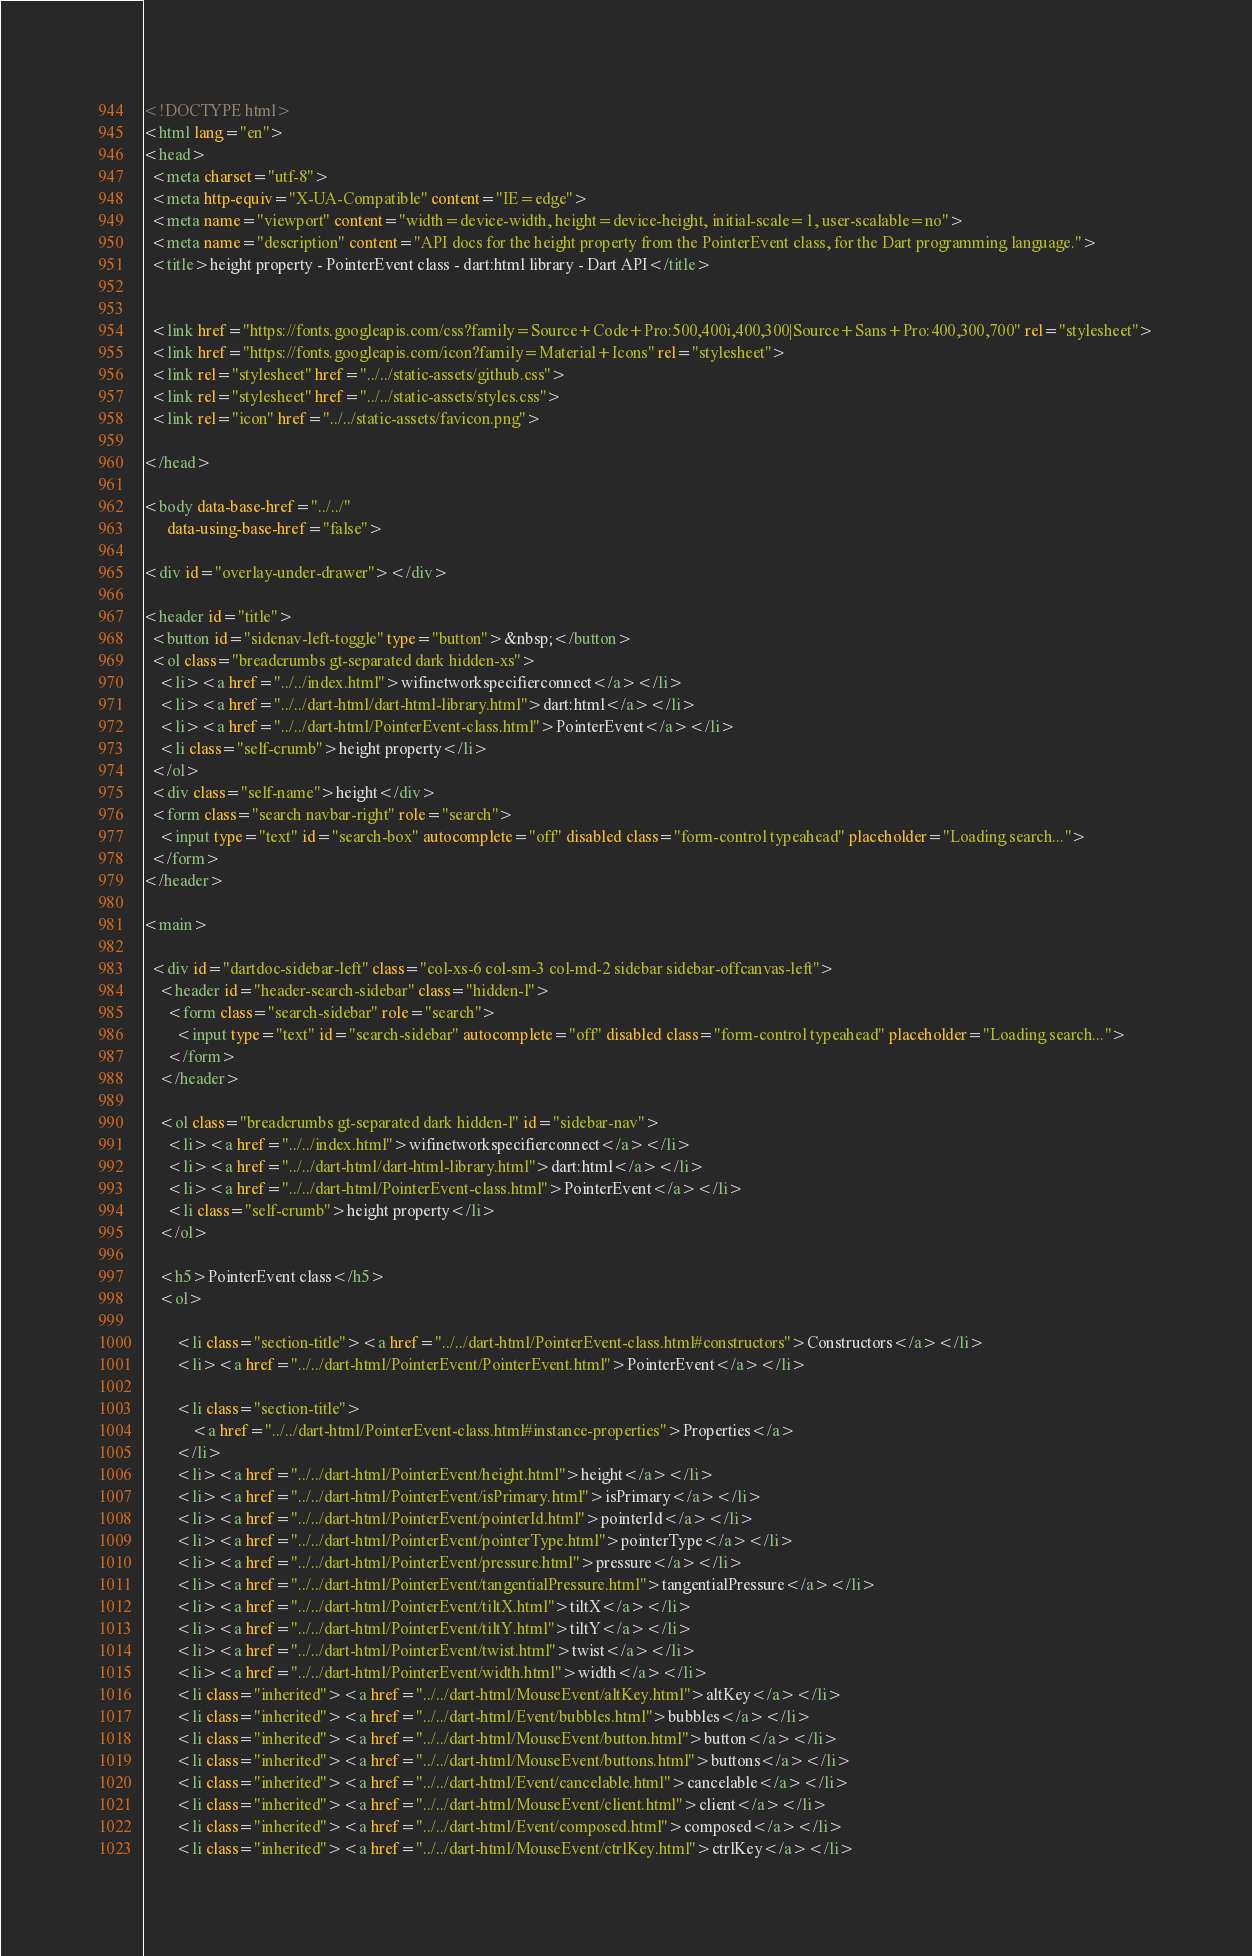Convert code to text. <code><loc_0><loc_0><loc_500><loc_500><_HTML_><!DOCTYPE html>
<html lang="en">
<head>
  <meta charset="utf-8">
  <meta http-equiv="X-UA-Compatible" content="IE=edge">
  <meta name="viewport" content="width=device-width, height=device-height, initial-scale=1, user-scalable=no">
  <meta name="description" content="API docs for the height property from the PointerEvent class, for the Dart programming language.">
  <title>height property - PointerEvent class - dart:html library - Dart API</title>

  
  <link href="https://fonts.googleapis.com/css?family=Source+Code+Pro:500,400i,400,300|Source+Sans+Pro:400,300,700" rel="stylesheet">
  <link href="https://fonts.googleapis.com/icon?family=Material+Icons" rel="stylesheet">
  <link rel="stylesheet" href="../../static-assets/github.css">
  <link rel="stylesheet" href="../../static-assets/styles.css">
  <link rel="icon" href="../../static-assets/favicon.png">

</head>

<body data-base-href="../../"
      data-using-base-href="false">

<div id="overlay-under-drawer"></div>

<header id="title">
  <button id="sidenav-left-toggle" type="button">&nbsp;</button>
  <ol class="breadcrumbs gt-separated dark hidden-xs">
    <li><a href="../../index.html">wifinetworkspecifierconnect</a></li>
    <li><a href="../../dart-html/dart-html-library.html">dart:html</a></li>
    <li><a href="../../dart-html/PointerEvent-class.html">PointerEvent</a></li>
    <li class="self-crumb">height property</li>
  </ol>
  <div class="self-name">height</div>
  <form class="search navbar-right" role="search">
    <input type="text" id="search-box" autocomplete="off" disabled class="form-control typeahead" placeholder="Loading search...">
  </form>
</header>

<main>

  <div id="dartdoc-sidebar-left" class="col-xs-6 col-sm-3 col-md-2 sidebar sidebar-offcanvas-left">
    <header id="header-search-sidebar" class="hidden-l">
      <form class="search-sidebar" role="search">
        <input type="text" id="search-sidebar" autocomplete="off" disabled class="form-control typeahead" placeholder="Loading search...">
      </form>
    </header>
    
    <ol class="breadcrumbs gt-separated dark hidden-l" id="sidebar-nav">
      <li><a href="../../index.html">wifinetworkspecifierconnect</a></li>
      <li><a href="../../dart-html/dart-html-library.html">dart:html</a></li>
      <li><a href="../../dart-html/PointerEvent-class.html">PointerEvent</a></li>
      <li class="self-crumb">height property</li>
    </ol>
    
    <h5>PointerEvent class</h5>
    <ol>
    
        <li class="section-title"><a href="../../dart-html/PointerEvent-class.html#constructors">Constructors</a></li>
        <li><a href="../../dart-html/PointerEvent/PointerEvent.html">PointerEvent</a></li>
    
        <li class="section-title">
            <a href="../../dart-html/PointerEvent-class.html#instance-properties">Properties</a>
        </li>
        <li><a href="../../dart-html/PointerEvent/height.html">height</a></li>
        <li><a href="../../dart-html/PointerEvent/isPrimary.html">isPrimary</a></li>
        <li><a href="../../dart-html/PointerEvent/pointerId.html">pointerId</a></li>
        <li><a href="../../dart-html/PointerEvent/pointerType.html">pointerType</a></li>
        <li><a href="../../dart-html/PointerEvent/pressure.html">pressure</a></li>
        <li><a href="../../dart-html/PointerEvent/tangentialPressure.html">tangentialPressure</a></li>
        <li><a href="../../dart-html/PointerEvent/tiltX.html">tiltX</a></li>
        <li><a href="../../dart-html/PointerEvent/tiltY.html">tiltY</a></li>
        <li><a href="../../dart-html/PointerEvent/twist.html">twist</a></li>
        <li><a href="../../dart-html/PointerEvent/width.html">width</a></li>
        <li class="inherited"><a href="../../dart-html/MouseEvent/altKey.html">altKey</a></li>
        <li class="inherited"><a href="../../dart-html/Event/bubbles.html">bubbles</a></li>
        <li class="inherited"><a href="../../dart-html/MouseEvent/button.html">button</a></li>
        <li class="inherited"><a href="../../dart-html/MouseEvent/buttons.html">buttons</a></li>
        <li class="inherited"><a href="../../dart-html/Event/cancelable.html">cancelable</a></li>
        <li class="inherited"><a href="../../dart-html/MouseEvent/client.html">client</a></li>
        <li class="inherited"><a href="../../dart-html/Event/composed.html">composed</a></li>
        <li class="inherited"><a href="../../dart-html/MouseEvent/ctrlKey.html">ctrlKey</a></li></code> 